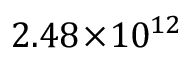<formula> <loc_0><loc_0><loc_500><loc_500>2 . 4 8 \, \times \, 1 0 ^ { 1 2 }</formula> 